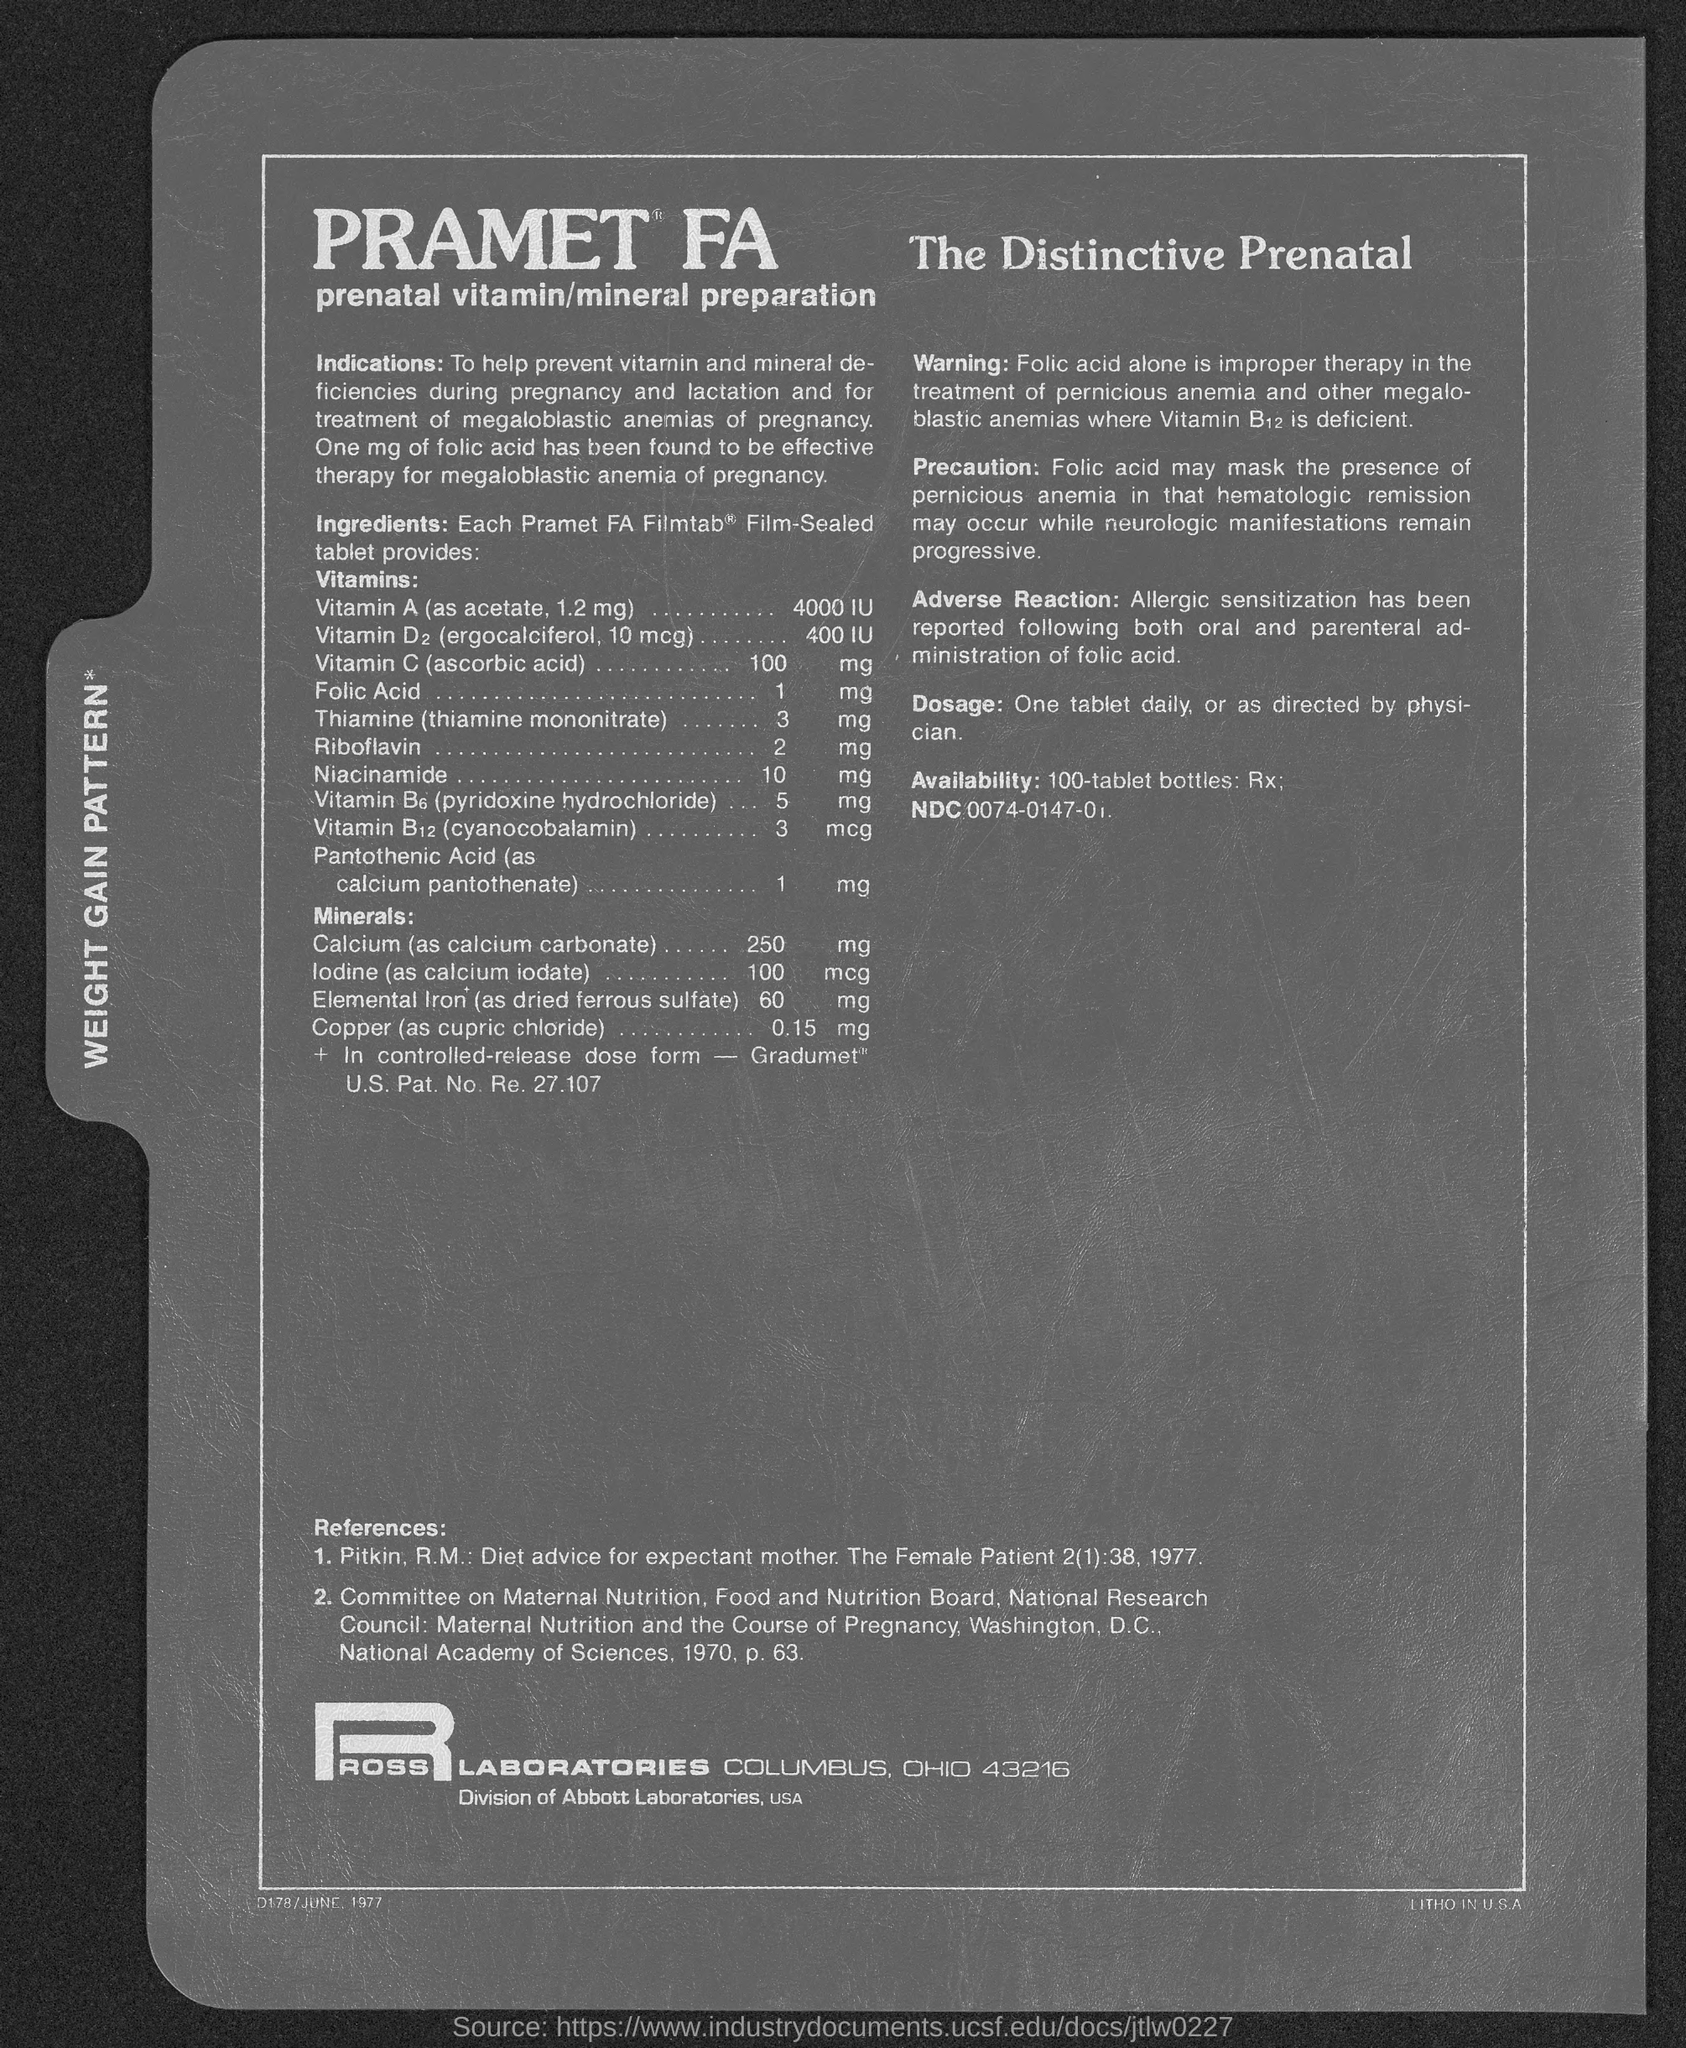Outline some significant characteristics in this image. Ross Laboratories is located in Columbus, Ohio, with a specific address of 43216. 